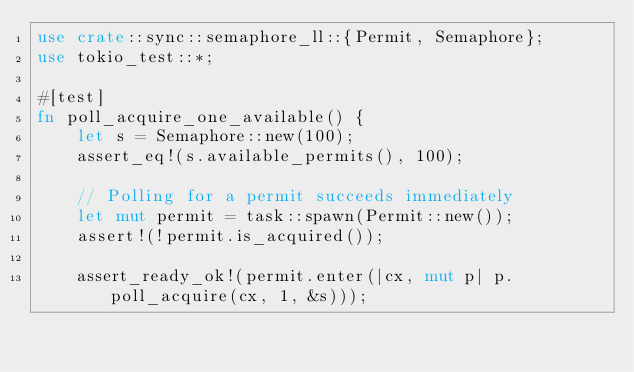<code> <loc_0><loc_0><loc_500><loc_500><_Rust_>use crate::sync::semaphore_ll::{Permit, Semaphore};
use tokio_test::*;

#[test]
fn poll_acquire_one_available() {
    let s = Semaphore::new(100);
    assert_eq!(s.available_permits(), 100);

    // Polling for a permit succeeds immediately
    let mut permit = task::spawn(Permit::new());
    assert!(!permit.is_acquired());

    assert_ready_ok!(permit.enter(|cx, mut p| p.poll_acquire(cx, 1, &s)));</code> 